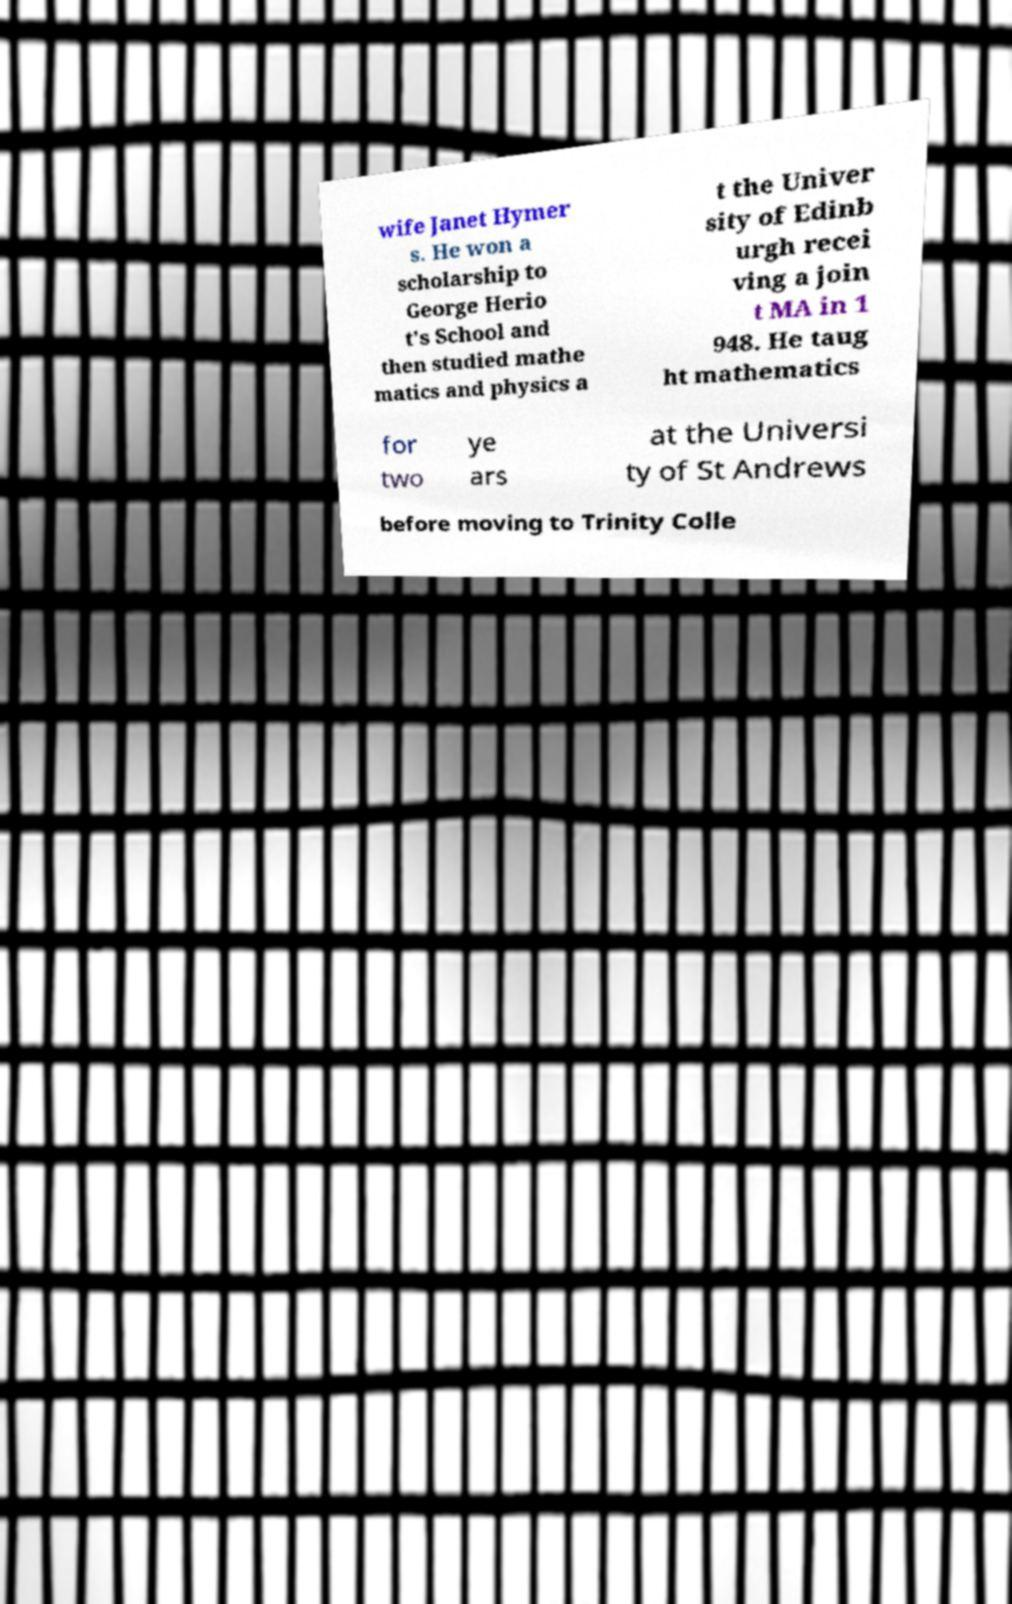Please read and relay the text visible in this image. What does it say? wife Janet Hymer s. He won a scholarship to George Herio t's School and then studied mathe matics and physics a t the Univer sity of Edinb urgh recei ving a join t MA in 1 948. He taug ht mathematics for two ye ars at the Universi ty of St Andrews before moving to Trinity Colle 